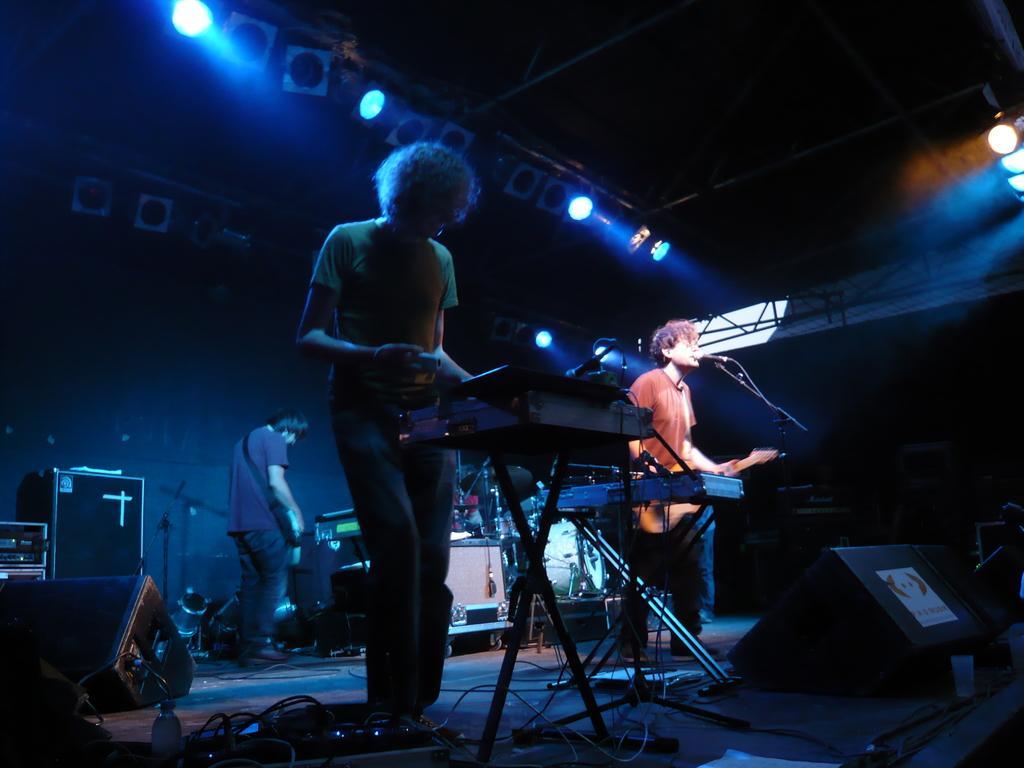In one or two sentences, can you explain what this image depicts? In this picture there are two musicians playing in a musical concert where one of the guy is playing a guitar and another is playing a piano. In the background we find many musical instruments and black boxes. There are also lights attached to the roof. 